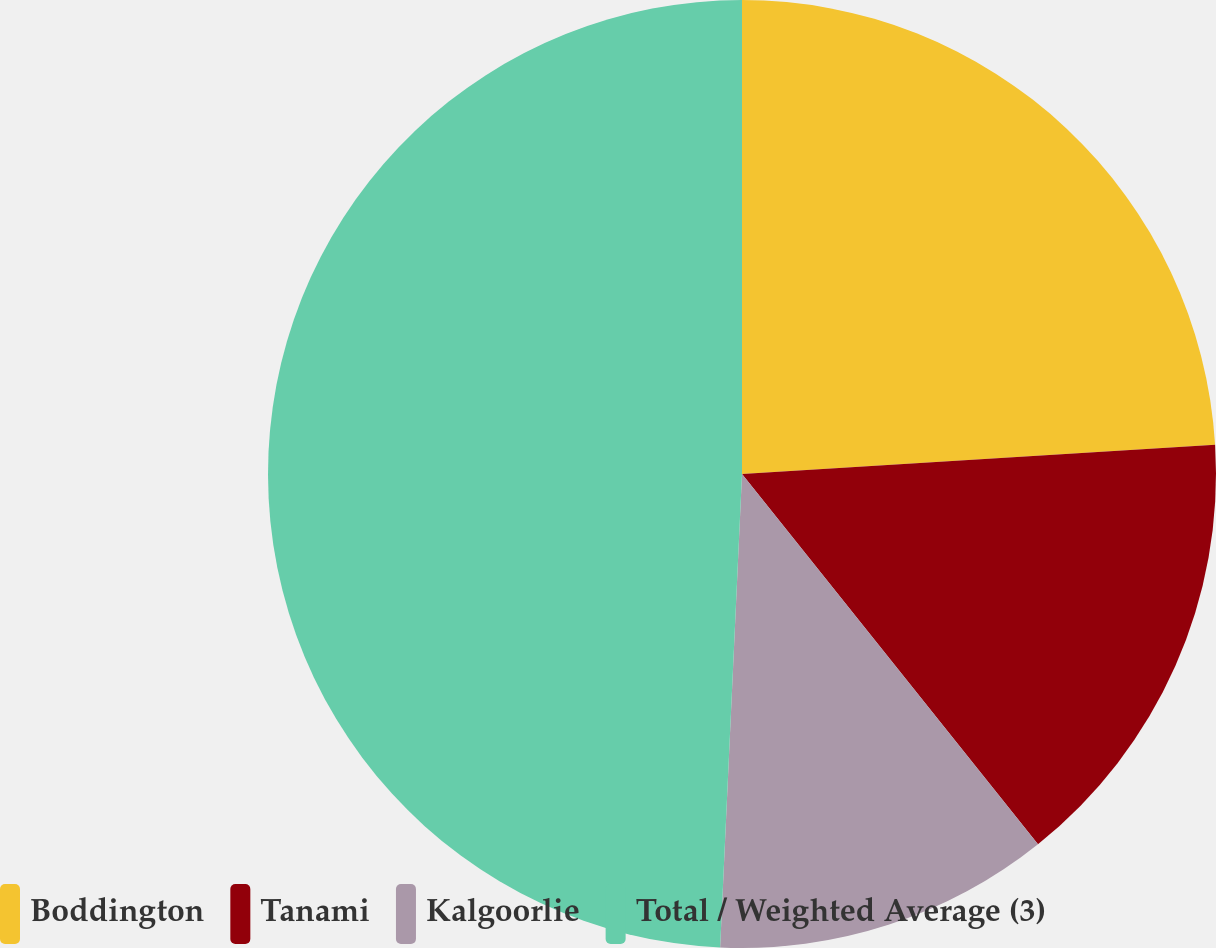Convert chart to OTSL. <chart><loc_0><loc_0><loc_500><loc_500><pie_chart><fcel>Boddington<fcel>Tanami<fcel>Kalgoorlie<fcel>Total / Weighted Average (3)<nl><fcel>24.02%<fcel>15.25%<fcel>11.47%<fcel>49.27%<nl></chart> 